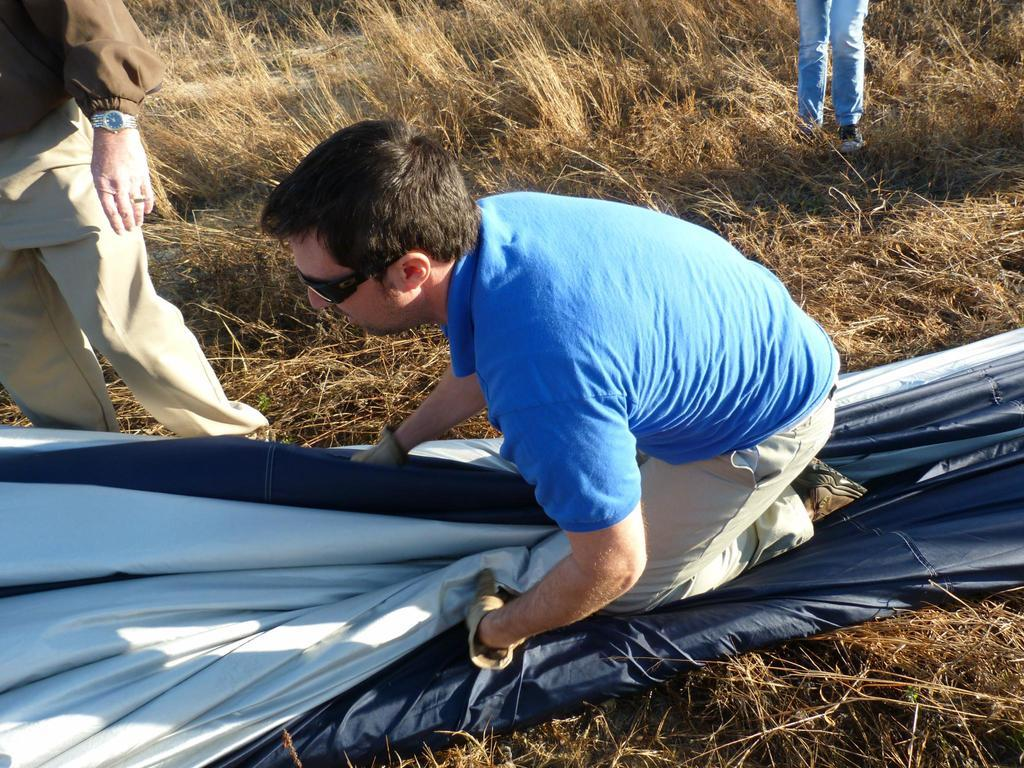What is the main subject in the middle of the image? There is a man sitting in the middle of the image. What is the man sitting on? The man is sitting on an object. What type of surface is visible on the ground in the image? There is grass on the ground in the image. How many other people are present in the image besides the man sitting down? There are two persons standing in the image. What type of book is the man reading in the image? There is no book or reading activity present in the image. 